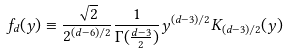Convert formula to latex. <formula><loc_0><loc_0><loc_500><loc_500>f _ { d } ( y ) \equiv \frac { \sqrt { 2 } } { 2 ^ { ( d - 6 ) / 2 } } \frac { 1 } { \Gamma ( \frac { d - 3 } { 2 } ) } y ^ { ( d - 3 ) / 2 } K _ { ( d - 3 ) / 2 } ( y )</formula> 